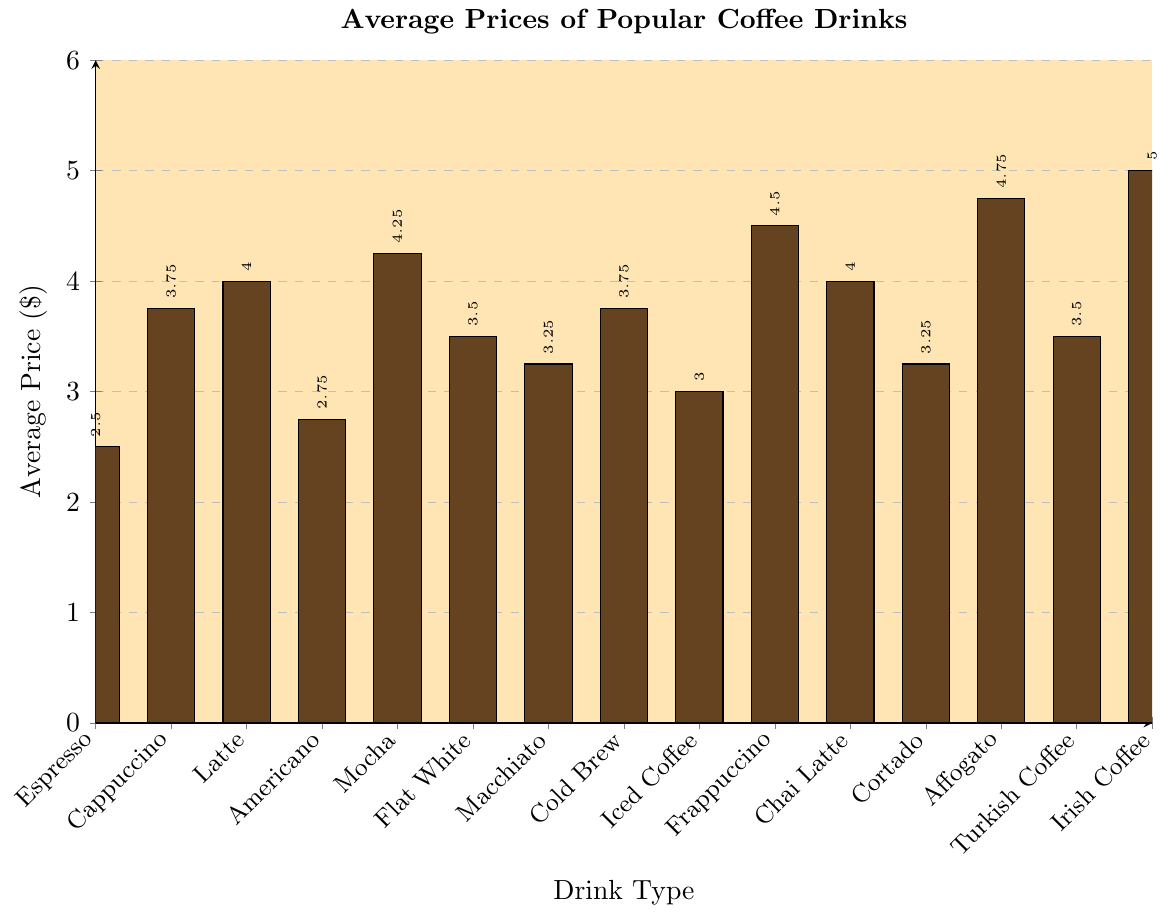What is the most expensive coffee drink based on the chart? The tallest bar on the chart represents the drink with the highest average price. By looking at the height of each bar, the tallest bar corresponds to Irish Coffee.
Answer: Irish Coffee How much more expensive is a Frappuccino compared to an Espresso? Identify the average price of both drinks from the chart: Frappuccino is $4.50 and Espresso is $2.50. Subtract the price of the Espresso from that of the Frappuccino: $4.50 - $2.50.
Answer: $2.00 Which is cheaper: a Cold Brew or a Cappuccino? Locate the bars corresponding to Cold Brew and Cappuccino. Cold Brew is priced at $3.75 and Cappuccino at $3.75. Since they have the same price, neither is cheaper.
Answer: They are the same price What is the total cost if a customer buys one of each of the three least expensive drinks? Identify the three least expensive drinks: Espresso ($2.50), Americano ($2.75), and Iced Coffee ($3.00). Sum their prices: $2.50 + $2.75 + $3.00.
Answer: $8.25 How many coffee drinks have an average price greater than or equal to $4.00? Count the bars that are at $4.00 or higher: Latte, Mocha, Frappuccino, Chai Latte, Affogato, Irish Coffee. There are six drinks.
Answer: 6 If the average price of Latte and Mocha is $4.13, verify if it is correct based on the chart. Extract the prices of Latte ($4.00) and Mocha ($4.25) from the chart. Calculate the average: ($4.00 + $4.25) / 2 = $4.125, approximately $4.13.
Answer: True What is the difference in average price between the most and least expensive drinks? The most expensive drink is Irish Coffee at $5.00 and the least expensive is Espresso at $2.50. Find the difference: $5.00 - $2.50.
Answer: $2.50 Which coffee drink has a higher average price: Macchiato or Cortado? Locate the bars for Macchiato and Cortado on the chart. Macchiato is $3.25 and Cortado is $3.25. Since both have the same price, neither has a higher price.
Answer: They are the same price What is the average price of all coffee drinks combined? Sum all the average prices: $2.50 + $3.75 + $4.00 + $2.75 + $4.25 + $3.50 + $3.25 + $3.75 + $3.00 + $4.50 + $4.00 + $3.25 + $4.75 + $3.50 + $5.00 = $56.75. Divide this by the number of drinks (15): $56.75 / 15.
Answer: $3.78 Which drink is more affordable: Turkish Coffee or Flat White? Locate the bars for Turkish Coffee and Flat White. Both have the same price of $3.50. Therefore, neither drink is more affordable.
Answer: They are the same price 